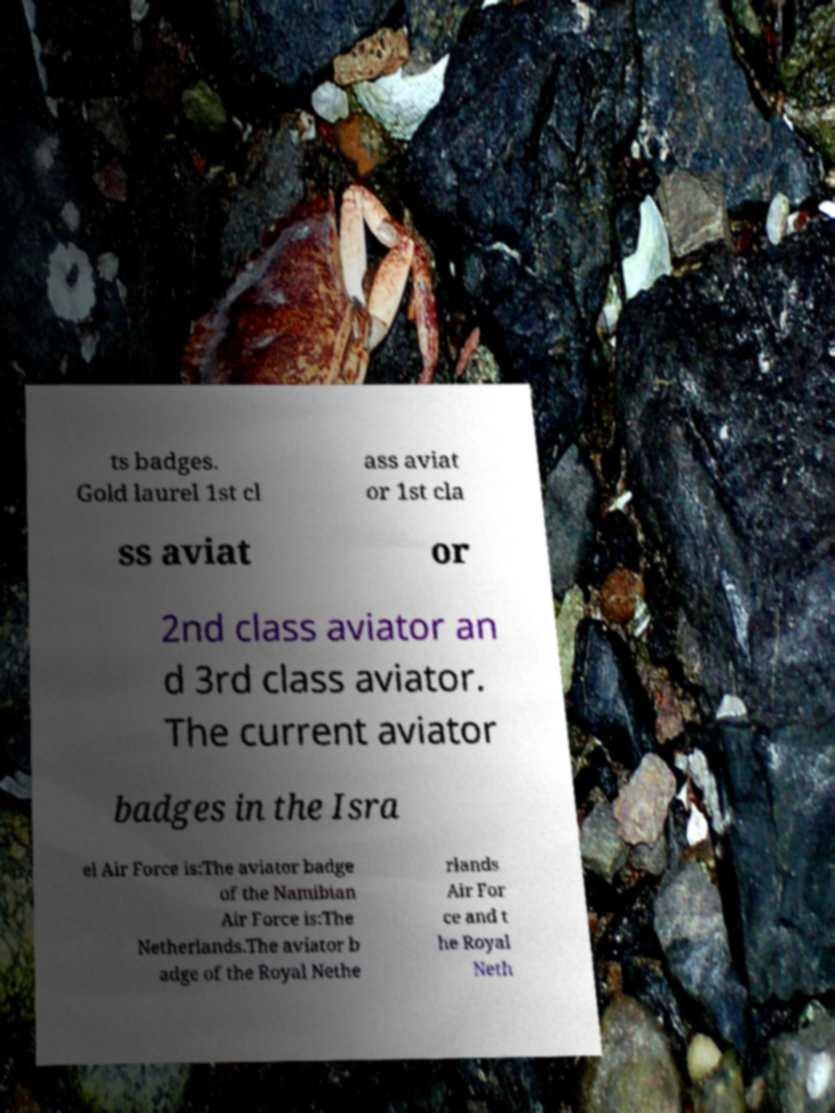Could you assist in decoding the text presented in this image and type it out clearly? ts badges. Gold laurel 1st cl ass aviat or 1st cla ss aviat or 2nd class aviator an d 3rd class aviator. The current aviator badges in the Isra el Air Force is:The aviator badge of the Namibian Air Force is:The Netherlands.The aviator b adge of the Royal Nethe rlands Air For ce and t he Royal Neth 